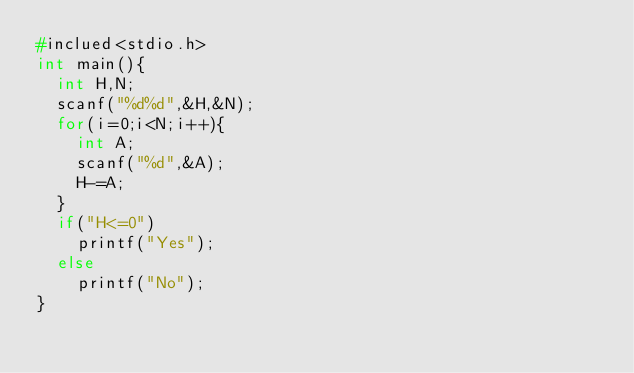<code> <loc_0><loc_0><loc_500><loc_500><_C_>#inclued<stdio.h>
int main(){
  int H,N;
  scanf("%d%d",&H,&N);
  for(i=0;i<N;i++){
    int A;
    scanf("%d",&A);
    H-=A;
  }
  if("H<=0")
    printf("Yes");
  else
    printf("No");
}</code> 